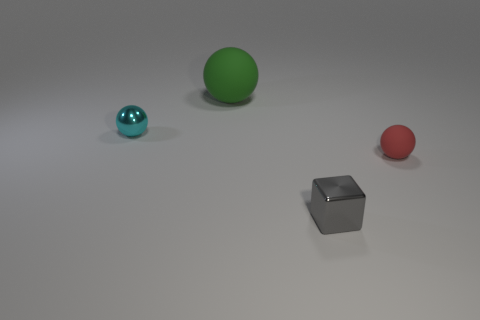Is there anything else that is the same shape as the small gray metal thing?
Ensure brevity in your answer.  No. How many other things are there of the same size as the cyan sphere?
Your response must be concise. 2. There is a ball that is both to the right of the tiny shiny sphere and on the left side of the small red sphere; what material is it?
Offer a terse response. Rubber. What size is the other metallic thing that is the same shape as the tiny red thing?
Give a very brief answer. Small. There is a object that is both to the right of the small shiny sphere and behind the small red ball; what shape is it?
Your answer should be compact. Sphere. There is a metallic cube; is its size the same as the rubber ball on the left side of the gray shiny block?
Offer a very short reply. No. The small metal thing that is the same shape as the big thing is what color?
Keep it short and to the point. Cyan. Does the metallic thing that is in front of the tiny rubber ball have the same size as the metal thing that is behind the tiny red ball?
Give a very brief answer. Yes. Do the big rubber object and the cyan thing have the same shape?
Your response must be concise. Yes. What number of things are cyan objects that are on the left side of the gray metallic cube or cyan blocks?
Your answer should be compact. 1. 